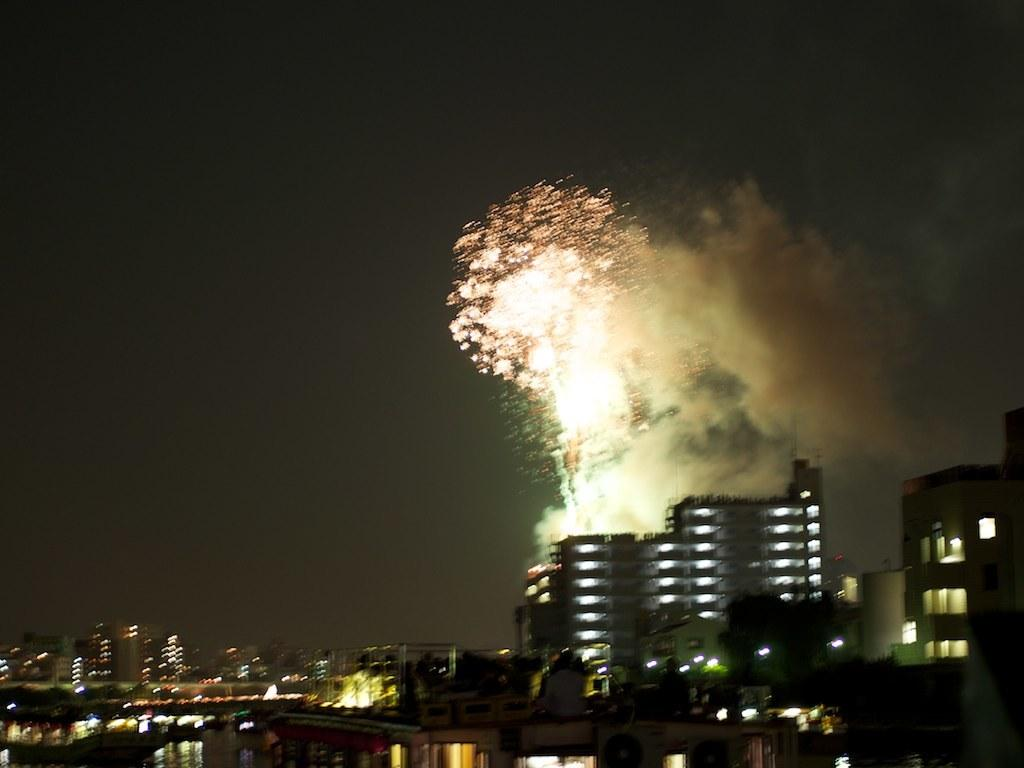What type of structures are present in the image? There is a group of buildings in the image. What natural element can be seen in the image? There is water visible in the image. What is visible in the background of the image? The sky is visible in the background of the image. What type of bomb can be seen in the image? There is no bomb present in the image. Can you hear the group of buildings laughing in the image? There is no sound or laughter present in the image; it is a still image of a group of buildings. 